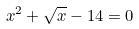Convert formula to latex. <formula><loc_0><loc_0><loc_500><loc_500>x ^ { 2 } + \sqrt { x } - 1 4 = 0</formula> 